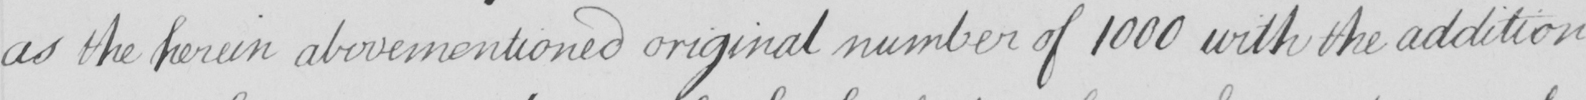Can you read and transcribe this handwriting? as the herein abovementioned original number of 1000 with the addition 